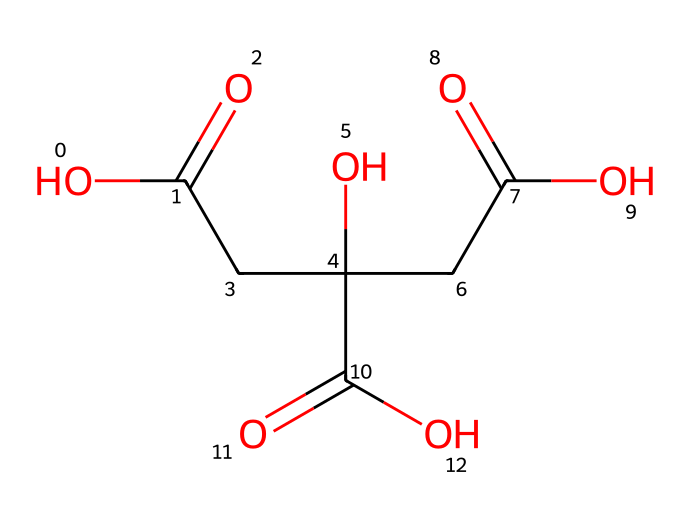How many carboxylic acid groups are present in this molecule? By analyzing the structural representation, we can identify the functional groups. The presence of -COOH (carboxylic acid) is noted three times in the structure, indicating three carboxylic acid groups.
Answer: three What is the total number of carbon atoms in this molecule? In the structure, we count the carbon atoms (C) represented in the SMILES notation. There are six carbon atoms displayed in the molecular structure.
Answer: six What type of acid is represented by this chemical structure? The chemical contains three carboxylic acid functional groups, characteristic of a triprotic acid, specifically known as citric acid due to its three acidic protons.
Answer: triprotic acid How many hydroxyl (-OH) groups are present in this molecule? By identifying the hydroxyl groups from the structure, there is one hydroxy (-OH) group noted in the representation, contributing to the properties of the molecule.
Answer: one What is the molecular formula based on the structural representation? By counting the atoms indicated in the structure — C, H, and O — we arrive at the molecular formula, which for citric acid is C6H8O7.
Answer: C6H8O7 What is the significance of the three carboxylic acid groups in terms of acidity? The presence of three carboxylic acids contributes to the acidity of this molecule, providing multiple protons (H+) that can dissociate in solution, which enhances the acidic nature.
Answer: enhances acidity 